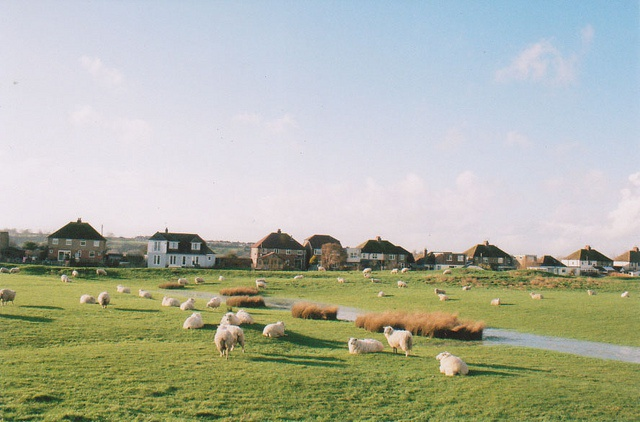Describe the objects in this image and their specific colors. I can see sheep in lavender, olive, gray, and tan tones, sheep in lavender, tan, lightgray, olive, and gray tones, sheep in lavender, tan, and lightgray tones, sheep in lavender, lightgray, and tan tones, and sheep in lavender, tan, gray, and lightgray tones in this image. 